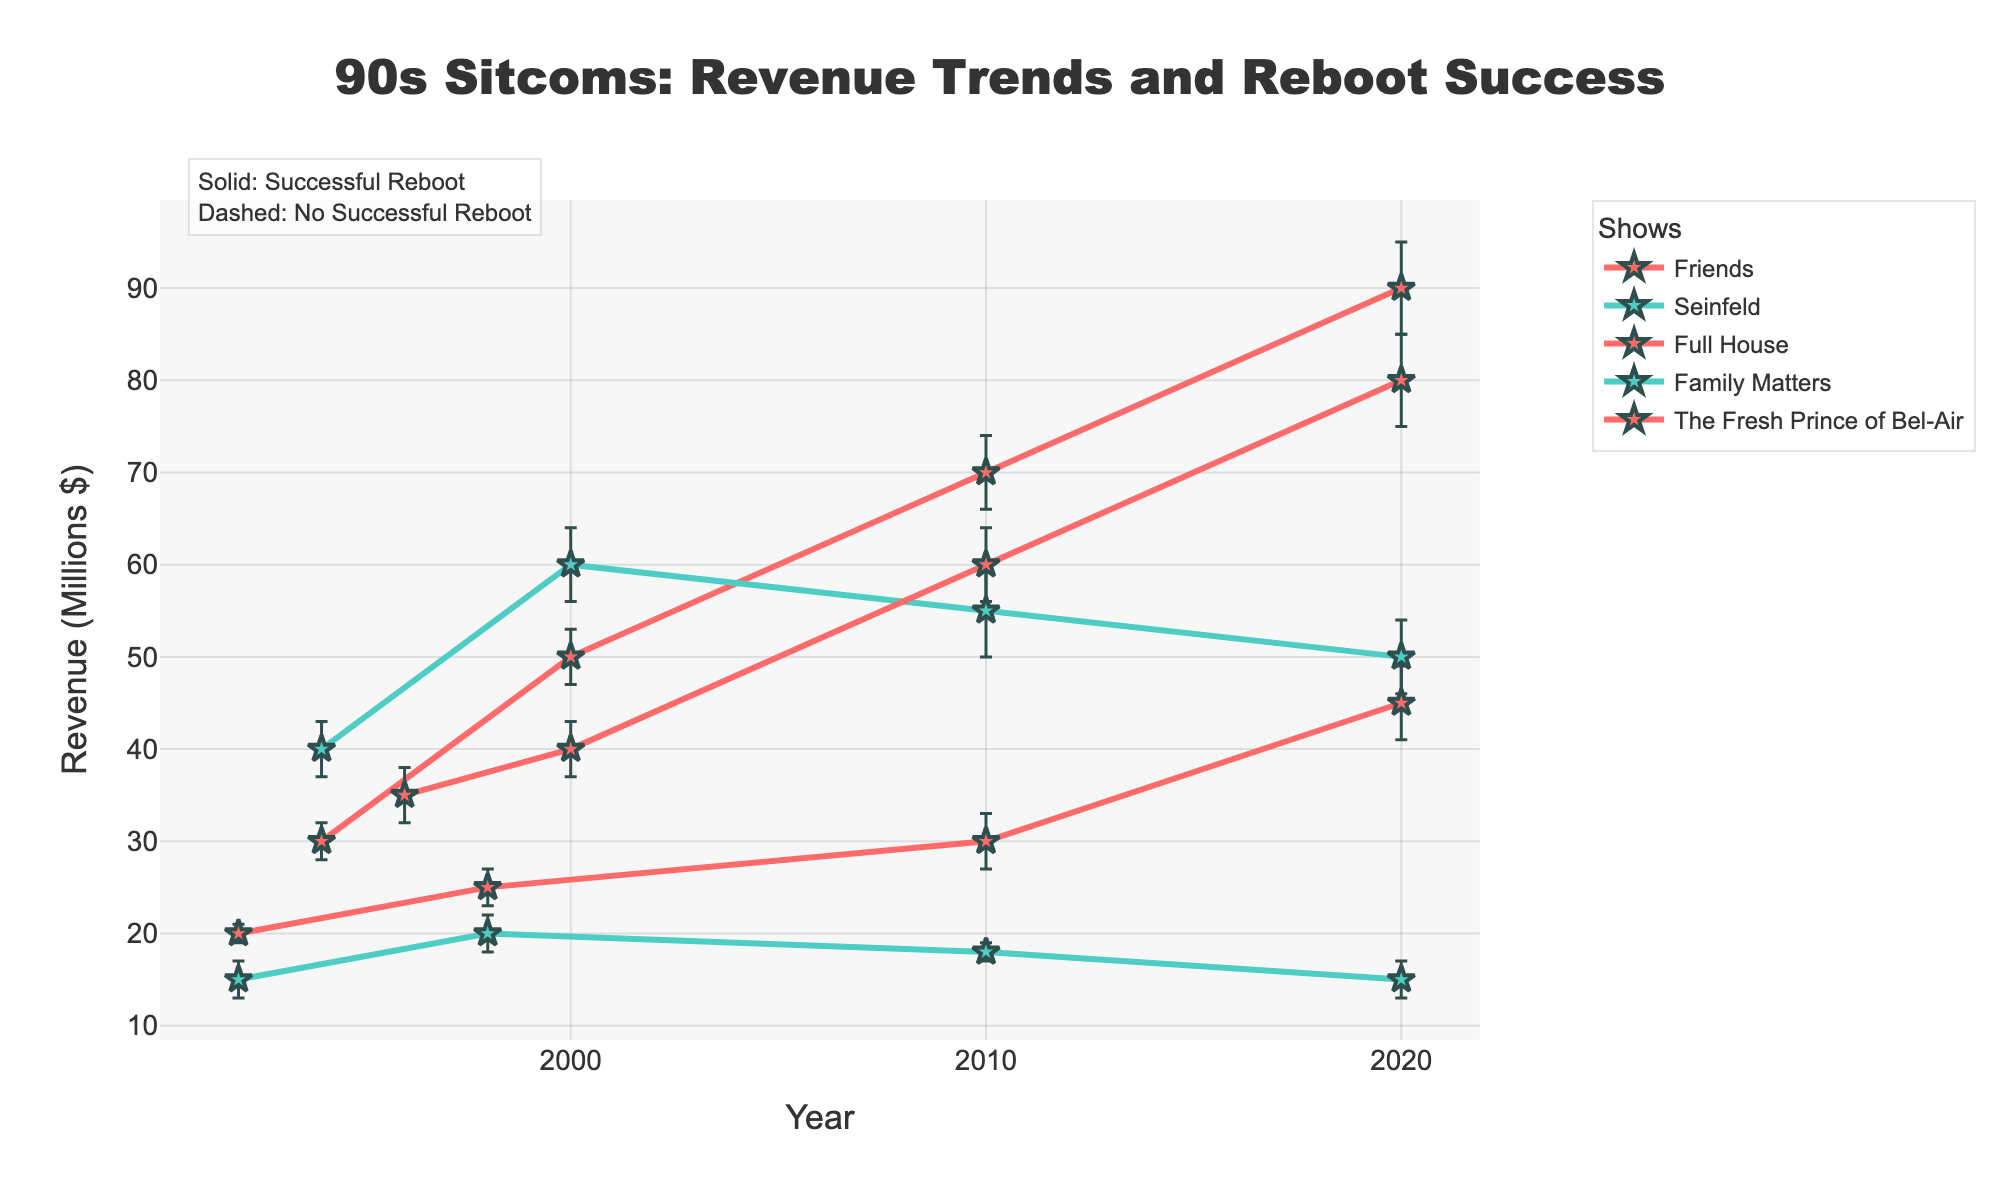What's the title of the figure? The title is usually prominently displayed at the top of the figure. It's meant to give a concise summary of the visualization.
Answer: "90s Sitcoms: Revenue Trends and Reboot Success" What is the x-axis representing? The x-axis indicates the variables over which the data is plotted. In this case, it's meant to show time intervals, specifically the years.
Answer: Year Which sitcom had the highest revenue in 2020? Look at the 2020 data points for all the sitcoms and compare their revenue values.
Answer: Friends Which sitcom did not have a successful reboot but had the highest initial revenue value? Compare the initial revenue values of sitcoms without successful reboots, marked with "No".
Answer: Seinfeld What color represents sitcoms with successful reboots? The color legend can help in identifying the status of reboots in the figure.
Answer: Red What is the trend of Family Matters revenue from 1992 to 2020? Trace the line related to Family Matters and observe how revenue values change from 1992 to 2020. There is a slight increase followed by a decline.
Answer: Increased until 1998, then decreased Which show's revenue had the largest error margin in 2010? Check the error bars for each show in the year 2010 and find the largest one.
Answer: Friends Calculate the difference in revenue for Full House between 2010 and 2020. Subtract the revenue of Full House in 2010 from its revenue in 2020.
Answer: 15 million $ Are any sitcoms showing a declining revenue trend overall? Trace lines for each sitcom and identify if any show consistently decreases in revenue.
Answer: Seinfeld, Family Matters Which show had a significant spike in revenue after 2010? Look at the revenue data from 2010 to 2020 and note any shows with a marked increase.
Answer: The Fresh Prince of Bel-Air 